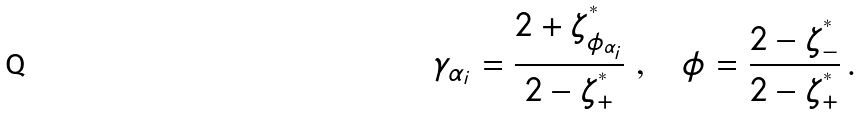Convert formula to latex. <formula><loc_0><loc_0><loc_500><loc_500>\gamma _ { \alpha _ { i } } = \frac { 2 + \zeta _ { \phi _ { \alpha _ { i } } } ^ { ^ { * } } } { 2 - \zeta _ { + } ^ { ^ { * } } } \ , \quad \phi = \frac { 2 - \zeta _ { - } ^ { ^ { * } } } { 2 - \zeta _ { + } ^ { ^ { * } } } \, .</formula> 